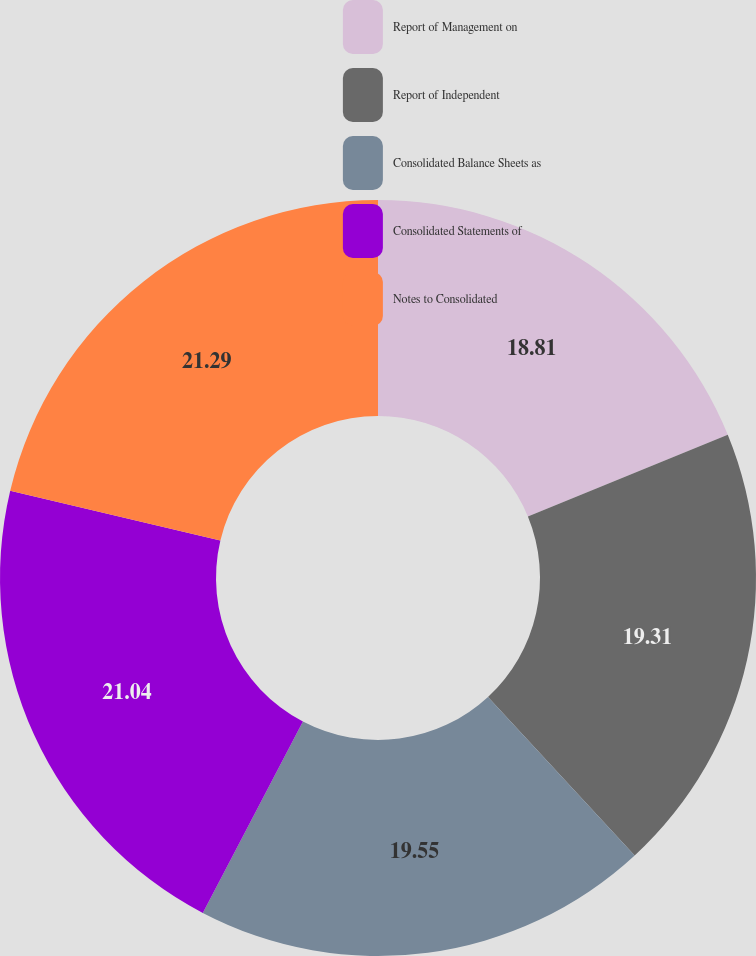Convert chart. <chart><loc_0><loc_0><loc_500><loc_500><pie_chart><fcel>Report of Management on<fcel>Report of Independent<fcel>Consolidated Balance Sheets as<fcel>Consolidated Statements of<fcel>Notes to Consolidated<nl><fcel>18.81%<fcel>19.31%<fcel>19.55%<fcel>21.04%<fcel>21.29%<nl></chart> 